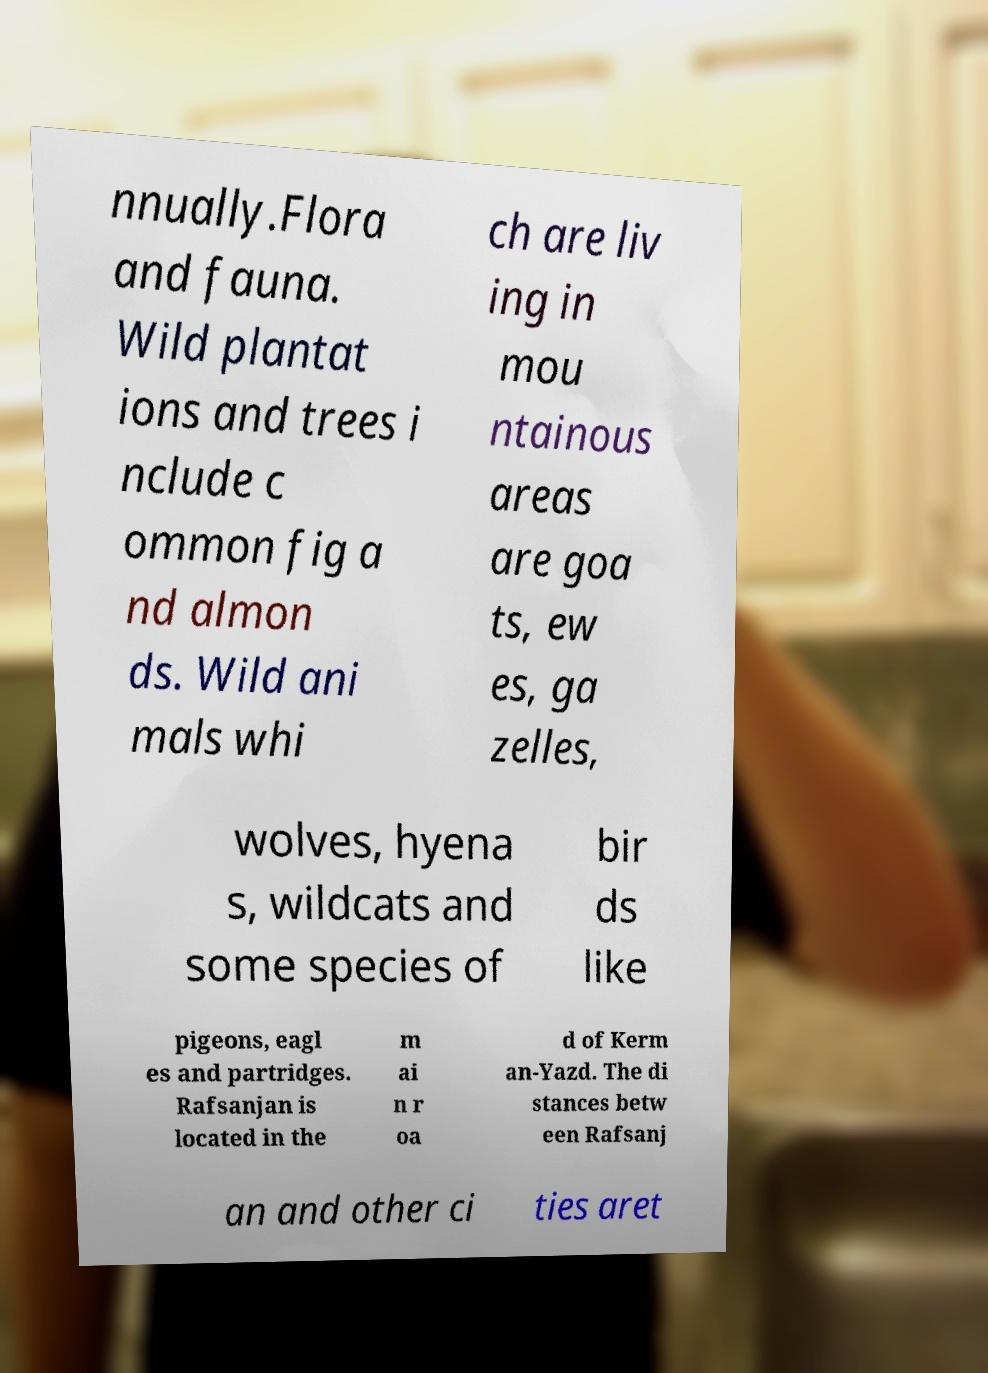Please identify and transcribe the text found in this image. nnually.Flora and fauna. Wild plantat ions and trees i nclude c ommon fig a nd almon ds. Wild ani mals whi ch are liv ing in mou ntainous areas are goa ts, ew es, ga zelles, wolves, hyena s, wildcats and some species of bir ds like pigeons, eagl es and partridges. Rafsanjan is located in the m ai n r oa d of Kerm an-Yazd. The di stances betw een Rafsanj an and other ci ties aret 